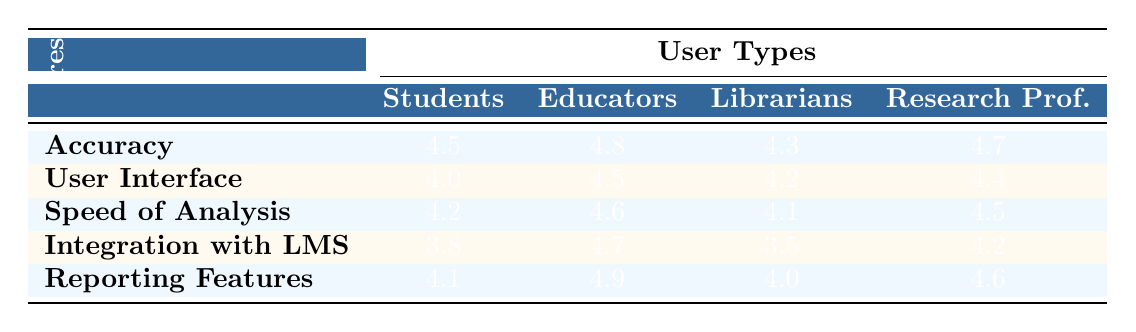What is the satisfaction rating for "User Interface" among Students? The table lists the satisfaction ratings for each feature and user type. Looking at the "User Interface" row and the "Students" column, the rating is 4.0.
Answer: 4.0 Which user type rated "Integration with LMS" the highest? The ratings for "Integration with LMS" are as follows: Students 3.8, Educators 4.7, Librarians 3.5, Research Professionals 4.2. The highest rating is from Educators with a score of 4.7.
Answer: Educators What is the average satisfaction rating for "Speed of Analysis"? The ratings for "Speed of Analysis" are: Students 4.2, Educators 4.6, Librarians 4.1, Research Professionals 4.5. Summing these gives 4.2 + 4.6 + 4.1 + 4.5 = 17.4. There are 4 user types, so the average is 17.4 / 4 = 4.35.
Answer: 4.35 Did any user type rate "Reporting Features" below 4.0? The ratings for "Reporting Features" are: Students 4.1, Educators 4.9, Librarians 4.0, Research Professionals 4.6. None of these ratings is below 4.0, as all are at least 4.0 or higher.
Answer: No Which feature received the highest overall average satisfaction rating? The ratings for each feature can be summed and averaged. For accuracy: (4.5 + 4.8 + 4.3 + 4.7) / 4 = 4.575; User Interface: (4.0 + 4.5 + 4.2 + 4.4) / 4 = 4.275; Speed of Analysis: (4.2 + 4.6 + 4.1 + 4.5) / 4 = 4.35; Integration with LMS: (3.8 + 4.7 + 3.5 + 4.2) / 4 = 4.05; Reporting Features: (4.1 + 4.9 + 4.0 + 4.6) / 4 = 4.40. The highest average is for Accuracy with 4.575.
Answer: Accuracy 